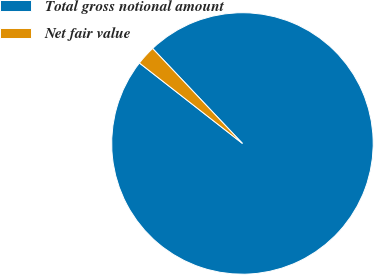<chart> <loc_0><loc_0><loc_500><loc_500><pie_chart><fcel>Total gross notional amount<fcel>Net fair value<nl><fcel>97.61%<fcel>2.39%<nl></chart> 